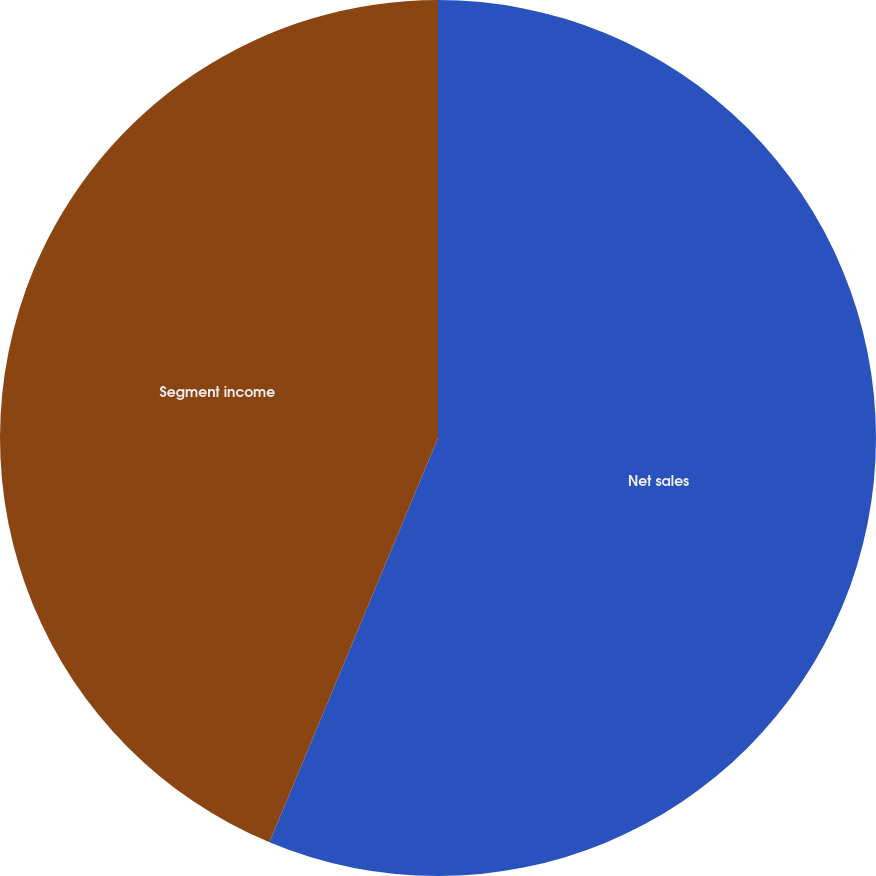Convert chart to OTSL. <chart><loc_0><loc_0><loc_500><loc_500><pie_chart><fcel>Net sales<fcel>Segment income<nl><fcel>56.29%<fcel>43.71%<nl></chart> 